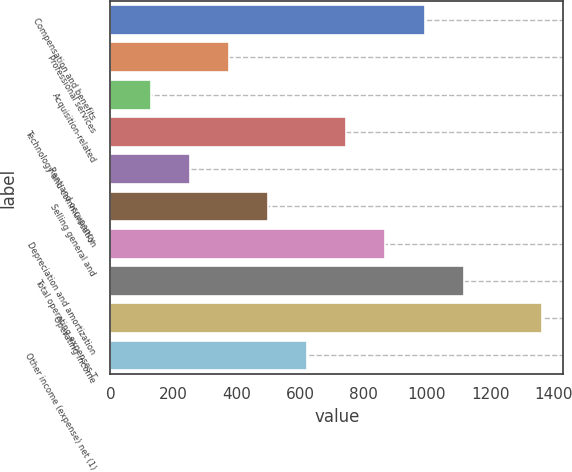<chart> <loc_0><loc_0><loc_500><loc_500><bar_chart><fcel>Compensation and benefits<fcel>Professional services<fcel>Acquisition-related<fcel>Technology and communication<fcel>Rent and occupancy<fcel>Selling general and<fcel>Depreciation and amortization<fcel>Total operating expenses T<fcel>Operating income<fcel>Other income (expense) net (1)<nl><fcel>992.4<fcel>375.9<fcel>129.3<fcel>745.8<fcel>252.6<fcel>499.2<fcel>869.1<fcel>1115.7<fcel>1362.3<fcel>622.5<nl></chart> 